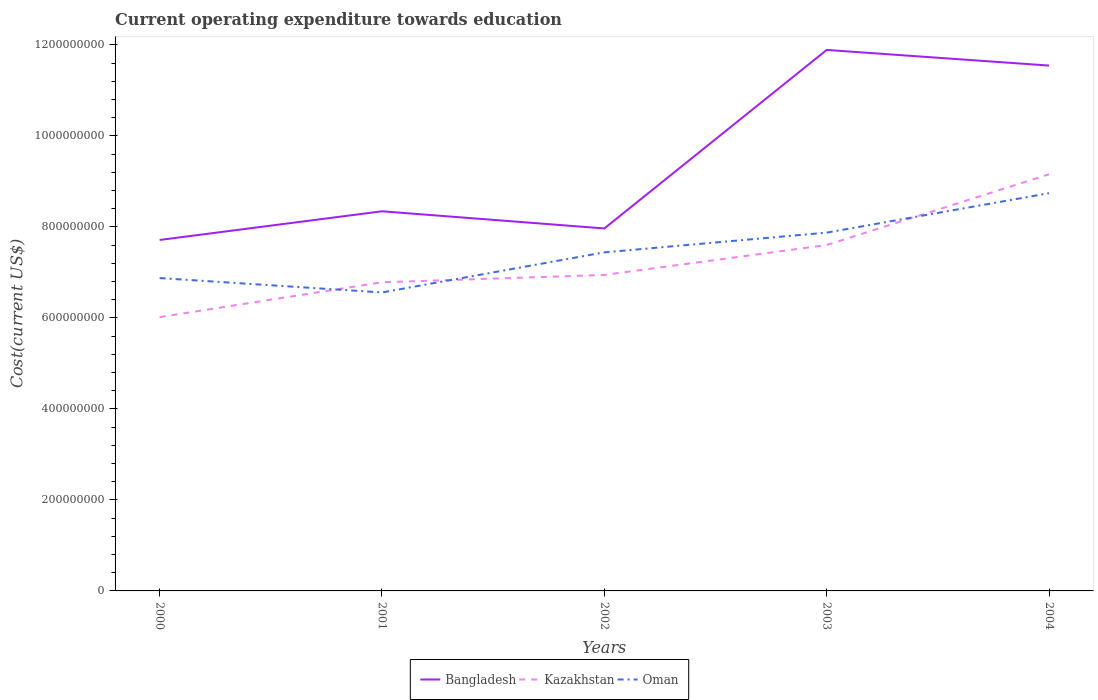How many different coloured lines are there?
Make the answer very short. 3. Does the line corresponding to Kazakhstan intersect with the line corresponding to Oman?
Provide a succinct answer. Yes. Is the number of lines equal to the number of legend labels?
Offer a very short reply. Yes. Across all years, what is the maximum expenditure towards education in Bangladesh?
Ensure brevity in your answer.  7.71e+08. In which year was the expenditure towards education in Oman maximum?
Your answer should be very brief. 2001. What is the total expenditure towards education in Oman in the graph?
Offer a very short reply. -5.65e+07. What is the difference between the highest and the second highest expenditure towards education in Oman?
Provide a succinct answer. 2.18e+08. Is the expenditure towards education in Bangladesh strictly greater than the expenditure towards education in Oman over the years?
Provide a succinct answer. No. How many years are there in the graph?
Keep it short and to the point. 5. Are the values on the major ticks of Y-axis written in scientific E-notation?
Your answer should be very brief. No. Does the graph contain grids?
Your answer should be compact. No. Where does the legend appear in the graph?
Offer a very short reply. Bottom center. How are the legend labels stacked?
Offer a very short reply. Horizontal. What is the title of the graph?
Provide a short and direct response. Current operating expenditure towards education. Does "Haiti" appear as one of the legend labels in the graph?
Offer a very short reply. No. What is the label or title of the X-axis?
Your answer should be very brief. Years. What is the label or title of the Y-axis?
Give a very brief answer. Cost(current US$). What is the Cost(current US$) of Bangladesh in 2000?
Offer a terse response. 7.71e+08. What is the Cost(current US$) of Kazakhstan in 2000?
Your response must be concise. 6.02e+08. What is the Cost(current US$) of Oman in 2000?
Provide a succinct answer. 6.88e+08. What is the Cost(current US$) in Bangladesh in 2001?
Keep it short and to the point. 8.34e+08. What is the Cost(current US$) in Kazakhstan in 2001?
Make the answer very short. 6.78e+08. What is the Cost(current US$) of Oman in 2001?
Ensure brevity in your answer.  6.56e+08. What is the Cost(current US$) of Bangladesh in 2002?
Keep it short and to the point. 7.97e+08. What is the Cost(current US$) in Kazakhstan in 2002?
Offer a terse response. 6.95e+08. What is the Cost(current US$) of Oman in 2002?
Ensure brevity in your answer.  7.44e+08. What is the Cost(current US$) of Bangladesh in 2003?
Keep it short and to the point. 1.19e+09. What is the Cost(current US$) in Kazakhstan in 2003?
Offer a terse response. 7.60e+08. What is the Cost(current US$) in Oman in 2003?
Offer a very short reply. 7.88e+08. What is the Cost(current US$) in Bangladesh in 2004?
Provide a short and direct response. 1.15e+09. What is the Cost(current US$) of Kazakhstan in 2004?
Your response must be concise. 9.16e+08. What is the Cost(current US$) of Oman in 2004?
Offer a terse response. 8.74e+08. Across all years, what is the maximum Cost(current US$) of Bangladesh?
Provide a short and direct response. 1.19e+09. Across all years, what is the maximum Cost(current US$) of Kazakhstan?
Give a very brief answer. 9.16e+08. Across all years, what is the maximum Cost(current US$) in Oman?
Your answer should be compact. 8.74e+08. Across all years, what is the minimum Cost(current US$) in Bangladesh?
Provide a short and direct response. 7.71e+08. Across all years, what is the minimum Cost(current US$) in Kazakhstan?
Your answer should be compact. 6.02e+08. Across all years, what is the minimum Cost(current US$) in Oman?
Provide a short and direct response. 6.56e+08. What is the total Cost(current US$) in Bangladesh in the graph?
Keep it short and to the point. 4.75e+09. What is the total Cost(current US$) of Kazakhstan in the graph?
Offer a very short reply. 3.65e+09. What is the total Cost(current US$) of Oman in the graph?
Provide a succinct answer. 3.75e+09. What is the difference between the Cost(current US$) in Bangladesh in 2000 and that in 2001?
Make the answer very short. -6.30e+07. What is the difference between the Cost(current US$) in Kazakhstan in 2000 and that in 2001?
Offer a very short reply. -7.65e+07. What is the difference between the Cost(current US$) in Oman in 2000 and that in 2001?
Give a very brief answer. 3.16e+07. What is the difference between the Cost(current US$) in Bangladesh in 2000 and that in 2002?
Your answer should be compact. -2.53e+07. What is the difference between the Cost(current US$) in Kazakhstan in 2000 and that in 2002?
Your response must be concise. -9.27e+07. What is the difference between the Cost(current US$) in Oman in 2000 and that in 2002?
Your response must be concise. -5.65e+07. What is the difference between the Cost(current US$) of Bangladesh in 2000 and that in 2003?
Your answer should be very brief. -4.18e+08. What is the difference between the Cost(current US$) in Kazakhstan in 2000 and that in 2003?
Keep it short and to the point. -1.58e+08. What is the difference between the Cost(current US$) of Oman in 2000 and that in 2003?
Offer a very short reply. -9.99e+07. What is the difference between the Cost(current US$) of Bangladesh in 2000 and that in 2004?
Provide a short and direct response. -3.83e+08. What is the difference between the Cost(current US$) in Kazakhstan in 2000 and that in 2004?
Your response must be concise. -3.14e+08. What is the difference between the Cost(current US$) in Oman in 2000 and that in 2004?
Your answer should be very brief. -1.87e+08. What is the difference between the Cost(current US$) in Bangladesh in 2001 and that in 2002?
Provide a short and direct response. 3.77e+07. What is the difference between the Cost(current US$) of Kazakhstan in 2001 and that in 2002?
Your answer should be very brief. -1.62e+07. What is the difference between the Cost(current US$) in Oman in 2001 and that in 2002?
Offer a very short reply. -8.82e+07. What is the difference between the Cost(current US$) in Bangladesh in 2001 and that in 2003?
Your answer should be very brief. -3.55e+08. What is the difference between the Cost(current US$) in Kazakhstan in 2001 and that in 2003?
Offer a very short reply. -8.18e+07. What is the difference between the Cost(current US$) of Oman in 2001 and that in 2003?
Make the answer very short. -1.32e+08. What is the difference between the Cost(current US$) in Bangladesh in 2001 and that in 2004?
Your answer should be compact. -3.20e+08. What is the difference between the Cost(current US$) in Kazakhstan in 2001 and that in 2004?
Your answer should be compact. -2.37e+08. What is the difference between the Cost(current US$) of Oman in 2001 and that in 2004?
Your answer should be very brief. -2.18e+08. What is the difference between the Cost(current US$) of Bangladesh in 2002 and that in 2003?
Your response must be concise. -3.92e+08. What is the difference between the Cost(current US$) in Kazakhstan in 2002 and that in 2003?
Make the answer very short. -6.57e+07. What is the difference between the Cost(current US$) of Oman in 2002 and that in 2003?
Make the answer very short. -4.34e+07. What is the difference between the Cost(current US$) of Bangladesh in 2002 and that in 2004?
Offer a terse response. -3.58e+08. What is the difference between the Cost(current US$) of Kazakhstan in 2002 and that in 2004?
Your answer should be compact. -2.21e+08. What is the difference between the Cost(current US$) of Oman in 2002 and that in 2004?
Provide a short and direct response. -1.30e+08. What is the difference between the Cost(current US$) in Bangladesh in 2003 and that in 2004?
Your answer should be compact. 3.44e+07. What is the difference between the Cost(current US$) of Kazakhstan in 2003 and that in 2004?
Provide a succinct answer. -1.56e+08. What is the difference between the Cost(current US$) in Oman in 2003 and that in 2004?
Make the answer very short. -8.67e+07. What is the difference between the Cost(current US$) in Bangladesh in 2000 and the Cost(current US$) in Kazakhstan in 2001?
Your response must be concise. 9.30e+07. What is the difference between the Cost(current US$) of Bangladesh in 2000 and the Cost(current US$) of Oman in 2001?
Give a very brief answer. 1.15e+08. What is the difference between the Cost(current US$) of Kazakhstan in 2000 and the Cost(current US$) of Oman in 2001?
Keep it short and to the point. -5.41e+07. What is the difference between the Cost(current US$) of Bangladesh in 2000 and the Cost(current US$) of Kazakhstan in 2002?
Make the answer very short. 7.69e+07. What is the difference between the Cost(current US$) of Bangladesh in 2000 and the Cost(current US$) of Oman in 2002?
Offer a very short reply. 2.72e+07. What is the difference between the Cost(current US$) in Kazakhstan in 2000 and the Cost(current US$) in Oman in 2002?
Give a very brief answer. -1.42e+08. What is the difference between the Cost(current US$) of Bangladesh in 2000 and the Cost(current US$) of Kazakhstan in 2003?
Offer a terse response. 1.12e+07. What is the difference between the Cost(current US$) of Bangladesh in 2000 and the Cost(current US$) of Oman in 2003?
Give a very brief answer. -1.61e+07. What is the difference between the Cost(current US$) in Kazakhstan in 2000 and the Cost(current US$) in Oman in 2003?
Provide a succinct answer. -1.86e+08. What is the difference between the Cost(current US$) of Bangladesh in 2000 and the Cost(current US$) of Kazakhstan in 2004?
Give a very brief answer. -1.44e+08. What is the difference between the Cost(current US$) in Bangladesh in 2000 and the Cost(current US$) in Oman in 2004?
Your response must be concise. -1.03e+08. What is the difference between the Cost(current US$) in Kazakhstan in 2000 and the Cost(current US$) in Oman in 2004?
Give a very brief answer. -2.72e+08. What is the difference between the Cost(current US$) of Bangladesh in 2001 and the Cost(current US$) of Kazakhstan in 2002?
Your response must be concise. 1.40e+08. What is the difference between the Cost(current US$) of Bangladesh in 2001 and the Cost(current US$) of Oman in 2002?
Your answer should be compact. 9.03e+07. What is the difference between the Cost(current US$) in Kazakhstan in 2001 and the Cost(current US$) in Oman in 2002?
Ensure brevity in your answer.  -6.58e+07. What is the difference between the Cost(current US$) of Bangladesh in 2001 and the Cost(current US$) of Kazakhstan in 2003?
Offer a very short reply. 7.42e+07. What is the difference between the Cost(current US$) of Bangladesh in 2001 and the Cost(current US$) of Oman in 2003?
Ensure brevity in your answer.  4.69e+07. What is the difference between the Cost(current US$) in Kazakhstan in 2001 and the Cost(current US$) in Oman in 2003?
Your answer should be very brief. -1.09e+08. What is the difference between the Cost(current US$) in Bangladesh in 2001 and the Cost(current US$) in Kazakhstan in 2004?
Your answer should be compact. -8.13e+07. What is the difference between the Cost(current US$) in Bangladesh in 2001 and the Cost(current US$) in Oman in 2004?
Your answer should be very brief. -3.98e+07. What is the difference between the Cost(current US$) of Kazakhstan in 2001 and the Cost(current US$) of Oman in 2004?
Ensure brevity in your answer.  -1.96e+08. What is the difference between the Cost(current US$) in Bangladesh in 2002 and the Cost(current US$) in Kazakhstan in 2003?
Make the answer very short. 3.65e+07. What is the difference between the Cost(current US$) of Bangladesh in 2002 and the Cost(current US$) of Oman in 2003?
Ensure brevity in your answer.  9.16e+06. What is the difference between the Cost(current US$) of Kazakhstan in 2002 and the Cost(current US$) of Oman in 2003?
Ensure brevity in your answer.  -9.30e+07. What is the difference between the Cost(current US$) in Bangladesh in 2002 and the Cost(current US$) in Kazakhstan in 2004?
Your answer should be very brief. -1.19e+08. What is the difference between the Cost(current US$) of Bangladesh in 2002 and the Cost(current US$) of Oman in 2004?
Your response must be concise. -7.75e+07. What is the difference between the Cost(current US$) in Kazakhstan in 2002 and the Cost(current US$) in Oman in 2004?
Give a very brief answer. -1.80e+08. What is the difference between the Cost(current US$) in Bangladesh in 2003 and the Cost(current US$) in Kazakhstan in 2004?
Your answer should be very brief. 2.73e+08. What is the difference between the Cost(current US$) of Bangladesh in 2003 and the Cost(current US$) of Oman in 2004?
Your answer should be very brief. 3.15e+08. What is the difference between the Cost(current US$) of Kazakhstan in 2003 and the Cost(current US$) of Oman in 2004?
Keep it short and to the point. -1.14e+08. What is the average Cost(current US$) in Bangladesh per year?
Ensure brevity in your answer.  9.49e+08. What is the average Cost(current US$) in Kazakhstan per year?
Ensure brevity in your answer.  7.30e+08. What is the average Cost(current US$) of Oman per year?
Keep it short and to the point. 7.50e+08. In the year 2000, what is the difference between the Cost(current US$) in Bangladesh and Cost(current US$) in Kazakhstan?
Offer a terse response. 1.70e+08. In the year 2000, what is the difference between the Cost(current US$) in Bangladesh and Cost(current US$) in Oman?
Offer a very short reply. 8.38e+07. In the year 2000, what is the difference between the Cost(current US$) of Kazakhstan and Cost(current US$) of Oman?
Your answer should be very brief. -8.58e+07. In the year 2001, what is the difference between the Cost(current US$) in Bangladesh and Cost(current US$) in Kazakhstan?
Your answer should be very brief. 1.56e+08. In the year 2001, what is the difference between the Cost(current US$) of Bangladesh and Cost(current US$) of Oman?
Your answer should be compact. 1.78e+08. In the year 2001, what is the difference between the Cost(current US$) in Kazakhstan and Cost(current US$) in Oman?
Make the answer very short. 2.24e+07. In the year 2002, what is the difference between the Cost(current US$) of Bangladesh and Cost(current US$) of Kazakhstan?
Your answer should be compact. 1.02e+08. In the year 2002, what is the difference between the Cost(current US$) in Bangladesh and Cost(current US$) in Oman?
Your response must be concise. 5.25e+07. In the year 2002, what is the difference between the Cost(current US$) of Kazakhstan and Cost(current US$) of Oman?
Your answer should be compact. -4.96e+07. In the year 2003, what is the difference between the Cost(current US$) of Bangladesh and Cost(current US$) of Kazakhstan?
Give a very brief answer. 4.29e+08. In the year 2003, what is the difference between the Cost(current US$) in Bangladesh and Cost(current US$) in Oman?
Offer a terse response. 4.02e+08. In the year 2003, what is the difference between the Cost(current US$) of Kazakhstan and Cost(current US$) of Oman?
Offer a terse response. -2.73e+07. In the year 2004, what is the difference between the Cost(current US$) in Bangladesh and Cost(current US$) in Kazakhstan?
Make the answer very short. 2.39e+08. In the year 2004, what is the difference between the Cost(current US$) of Bangladesh and Cost(current US$) of Oman?
Your answer should be compact. 2.81e+08. In the year 2004, what is the difference between the Cost(current US$) in Kazakhstan and Cost(current US$) in Oman?
Your answer should be very brief. 4.16e+07. What is the ratio of the Cost(current US$) in Bangladesh in 2000 to that in 2001?
Make the answer very short. 0.92. What is the ratio of the Cost(current US$) in Kazakhstan in 2000 to that in 2001?
Your answer should be very brief. 0.89. What is the ratio of the Cost(current US$) of Oman in 2000 to that in 2001?
Your response must be concise. 1.05. What is the ratio of the Cost(current US$) in Bangladesh in 2000 to that in 2002?
Make the answer very short. 0.97. What is the ratio of the Cost(current US$) of Kazakhstan in 2000 to that in 2002?
Make the answer very short. 0.87. What is the ratio of the Cost(current US$) in Oman in 2000 to that in 2002?
Your answer should be very brief. 0.92. What is the ratio of the Cost(current US$) of Bangladesh in 2000 to that in 2003?
Your answer should be very brief. 0.65. What is the ratio of the Cost(current US$) in Kazakhstan in 2000 to that in 2003?
Offer a terse response. 0.79. What is the ratio of the Cost(current US$) in Oman in 2000 to that in 2003?
Provide a short and direct response. 0.87. What is the ratio of the Cost(current US$) in Bangladesh in 2000 to that in 2004?
Keep it short and to the point. 0.67. What is the ratio of the Cost(current US$) of Kazakhstan in 2000 to that in 2004?
Offer a very short reply. 0.66. What is the ratio of the Cost(current US$) in Oman in 2000 to that in 2004?
Your response must be concise. 0.79. What is the ratio of the Cost(current US$) of Bangladesh in 2001 to that in 2002?
Make the answer very short. 1.05. What is the ratio of the Cost(current US$) of Kazakhstan in 2001 to that in 2002?
Give a very brief answer. 0.98. What is the ratio of the Cost(current US$) in Oman in 2001 to that in 2002?
Your answer should be very brief. 0.88. What is the ratio of the Cost(current US$) of Bangladesh in 2001 to that in 2003?
Provide a short and direct response. 0.7. What is the ratio of the Cost(current US$) of Kazakhstan in 2001 to that in 2003?
Provide a succinct answer. 0.89. What is the ratio of the Cost(current US$) in Oman in 2001 to that in 2003?
Keep it short and to the point. 0.83. What is the ratio of the Cost(current US$) of Bangladesh in 2001 to that in 2004?
Your answer should be compact. 0.72. What is the ratio of the Cost(current US$) of Kazakhstan in 2001 to that in 2004?
Your response must be concise. 0.74. What is the ratio of the Cost(current US$) in Oman in 2001 to that in 2004?
Offer a very short reply. 0.75. What is the ratio of the Cost(current US$) of Bangladesh in 2002 to that in 2003?
Your answer should be very brief. 0.67. What is the ratio of the Cost(current US$) in Kazakhstan in 2002 to that in 2003?
Keep it short and to the point. 0.91. What is the ratio of the Cost(current US$) in Oman in 2002 to that in 2003?
Provide a succinct answer. 0.94. What is the ratio of the Cost(current US$) in Bangladesh in 2002 to that in 2004?
Give a very brief answer. 0.69. What is the ratio of the Cost(current US$) in Kazakhstan in 2002 to that in 2004?
Provide a short and direct response. 0.76. What is the ratio of the Cost(current US$) in Oman in 2002 to that in 2004?
Keep it short and to the point. 0.85. What is the ratio of the Cost(current US$) of Bangladesh in 2003 to that in 2004?
Make the answer very short. 1.03. What is the ratio of the Cost(current US$) in Kazakhstan in 2003 to that in 2004?
Provide a succinct answer. 0.83. What is the ratio of the Cost(current US$) in Oman in 2003 to that in 2004?
Your answer should be compact. 0.9. What is the difference between the highest and the second highest Cost(current US$) in Bangladesh?
Give a very brief answer. 3.44e+07. What is the difference between the highest and the second highest Cost(current US$) in Kazakhstan?
Offer a very short reply. 1.56e+08. What is the difference between the highest and the second highest Cost(current US$) of Oman?
Offer a very short reply. 8.67e+07. What is the difference between the highest and the lowest Cost(current US$) in Bangladesh?
Keep it short and to the point. 4.18e+08. What is the difference between the highest and the lowest Cost(current US$) in Kazakhstan?
Keep it short and to the point. 3.14e+08. What is the difference between the highest and the lowest Cost(current US$) in Oman?
Your answer should be compact. 2.18e+08. 